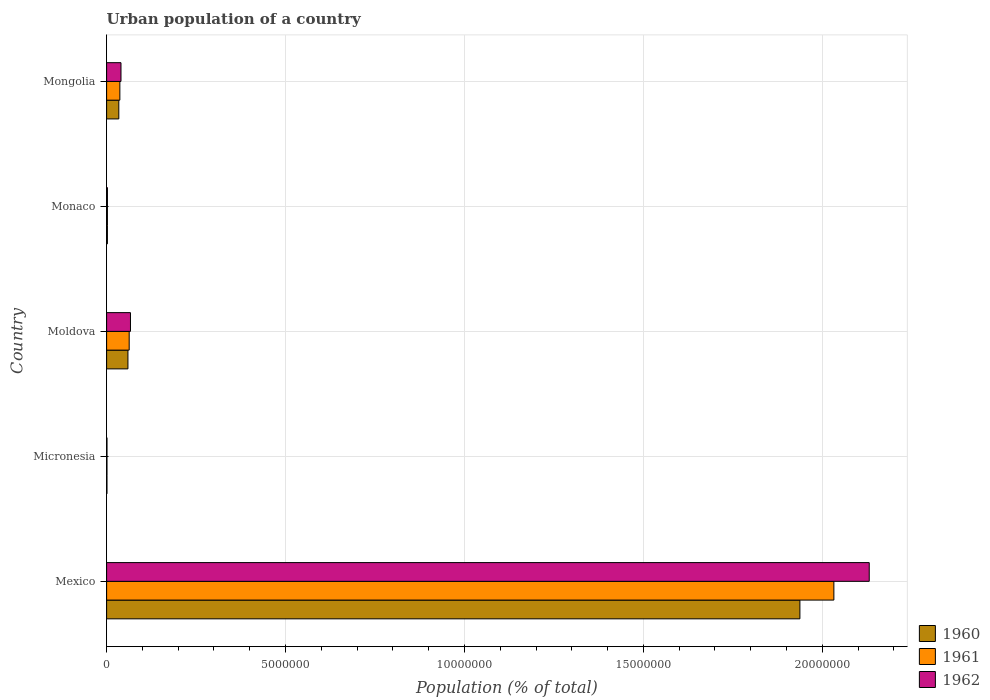How many different coloured bars are there?
Offer a terse response. 3. Are the number of bars on each tick of the Y-axis equal?
Your response must be concise. Yes. What is the label of the 3rd group of bars from the top?
Your answer should be compact. Moldova. What is the urban population in 1960 in Mexico?
Ensure brevity in your answer.  1.94e+07. Across all countries, what is the maximum urban population in 1961?
Your answer should be very brief. 2.03e+07. Across all countries, what is the minimum urban population in 1960?
Offer a very short reply. 9938. In which country was the urban population in 1962 maximum?
Keep it short and to the point. Mexico. In which country was the urban population in 1961 minimum?
Provide a short and direct response. Micronesia. What is the total urban population in 1962 in the graph?
Make the answer very short. 2.24e+07. What is the difference between the urban population in 1962 in Micronesia and that in Monaco?
Your answer should be compact. -1.22e+04. What is the difference between the urban population in 1962 in Monaco and the urban population in 1960 in Micronesia?
Your answer should be compact. 1.31e+04. What is the average urban population in 1960 per country?
Provide a short and direct response. 4.07e+06. What is the difference between the urban population in 1962 and urban population in 1960 in Moldova?
Your answer should be compact. 7.08e+04. What is the ratio of the urban population in 1962 in Mexico to that in Mongolia?
Ensure brevity in your answer.  53.04. Is the urban population in 1960 in Monaco less than that in Mongolia?
Your answer should be compact. Yes. What is the difference between the highest and the second highest urban population in 1961?
Offer a terse response. 1.97e+07. What is the difference between the highest and the lowest urban population in 1960?
Offer a terse response. 1.94e+07. In how many countries, is the urban population in 1962 greater than the average urban population in 1962 taken over all countries?
Your answer should be very brief. 1. What does the 3rd bar from the top in Moldova represents?
Your answer should be very brief. 1960. Is it the case that in every country, the sum of the urban population in 1962 and urban population in 1960 is greater than the urban population in 1961?
Your response must be concise. Yes. How many bars are there?
Offer a terse response. 15. How many countries are there in the graph?
Offer a terse response. 5. Are the values on the major ticks of X-axis written in scientific E-notation?
Ensure brevity in your answer.  No. Does the graph contain grids?
Keep it short and to the point. Yes. Where does the legend appear in the graph?
Ensure brevity in your answer.  Bottom right. How many legend labels are there?
Your response must be concise. 3. What is the title of the graph?
Keep it short and to the point. Urban population of a country. Does "1961" appear as one of the legend labels in the graph?
Make the answer very short. Yes. What is the label or title of the X-axis?
Your answer should be very brief. Population (% of total). What is the Population (% of total) in 1960 in Mexico?
Ensure brevity in your answer.  1.94e+07. What is the Population (% of total) of 1961 in Mexico?
Offer a terse response. 2.03e+07. What is the Population (% of total) of 1962 in Mexico?
Offer a very short reply. 2.13e+07. What is the Population (% of total) in 1960 in Micronesia?
Provide a short and direct response. 9938. What is the Population (% of total) of 1961 in Micronesia?
Give a very brief answer. 1.04e+04. What is the Population (% of total) in 1962 in Micronesia?
Your answer should be very brief. 1.08e+04. What is the Population (% of total) of 1960 in Moldova?
Ensure brevity in your answer.  5.96e+05. What is the Population (% of total) of 1961 in Moldova?
Your answer should be compact. 6.31e+05. What is the Population (% of total) in 1962 in Moldova?
Your answer should be compact. 6.67e+05. What is the Population (% of total) of 1960 in Monaco?
Your response must be concise. 2.25e+04. What is the Population (% of total) in 1961 in Monaco?
Keep it short and to the point. 2.28e+04. What is the Population (% of total) in 1962 in Monaco?
Provide a short and direct response. 2.30e+04. What is the Population (% of total) of 1960 in Mongolia?
Keep it short and to the point. 3.41e+05. What is the Population (% of total) in 1961 in Mongolia?
Make the answer very short. 3.70e+05. What is the Population (% of total) of 1962 in Mongolia?
Your answer should be very brief. 4.02e+05. Across all countries, what is the maximum Population (% of total) in 1960?
Offer a terse response. 1.94e+07. Across all countries, what is the maximum Population (% of total) in 1961?
Keep it short and to the point. 2.03e+07. Across all countries, what is the maximum Population (% of total) of 1962?
Your answer should be compact. 2.13e+07. Across all countries, what is the minimum Population (% of total) of 1960?
Offer a terse response. 9938. Across all countries, what is the minimum Population (% of total) of 1961?
Give a very brief answer. 1.04e+04. Across all countries, what is the minimum Population (% of total) in 1962?
Make the answer very short. 1.08e+04. What is the total Population (% of total) of 1960 in the graph?
Make the answer very short. 2.03e+07. What is the total Population (% of total) in 1961 in the graph?
Your answer should be very brief. 2.14e+07. What is the total Population (% of total) in 1962 in the graph?
Make the answer very short. 2.24e+07. What is the difference between the Population (% of total) in 1960 in Mexico and that in Micronesia?
Your answer should be very brief. 1.94e+07. What is the difference between the Population (% of total) of 1961 in Mexico and that in Micronesia?
Provide a succinct answer. 2.03e+07. What is the difference between the Population (% of total) in 1962 in Mexico and that in Micronesia?
Your answer should be very brief. 2.13e+07. What is the difference between the Population (% of total) of 1960 in Mexico and that in Moldova?
Give a very brief answer. 1.88e+07. What is the difference between the Population (% of total) of 1961 in Mexico and that in Moldova?
Offer a terse response. 1.97e+07. What is the difference between the Population (% of total) in 1962 in Mexico and that in Moldova?
Make the answer very short. 2.06e+07. What is the difference between the Population (% of total) of 1960 in Mexico and that in Monaco?
Keep it short and to the point. 1.94e+07. What is the difference between the Population (% of total) in 1961 in Mexico and that in Monaco?
Keep it short and to the point. 2.03e+07. What is the difference between the Population (% of total) in 1962 in Mexico and that in Monaco?
Your response must be concise. 2.13e+07. What is the difference between the Population (% of total) of 1960 in Mexico and that in Mongolia?
Make the answer very short. 1.90e+07. What is the difference between the Population (% of total) of 1961 in Mexico and that in Mongolia?
Provide a succinct answer. 2.00e+07. What is the difference between the Population (% of total) in 1962 in Mexico and that in Mongolia?
Offer a very short reply. 2.09e+07. What is the difference between the Population (% of total) in 1960 in Micronesia and that in Moldova?
Your answer should be compact. -5.86e+05. What is the difference between the Population (% of total) in 1961 in Micronesia and that in Moldova?
Provide a short and direct response. -6.20e+05. What is the difference between the Population (% of total) in 1962 in Micronesia and that in Moldova?
Your response must be concise. -6.56e+05. What is the difference between the Population (% of total) of 1960 in Micronesia and that in Monaco?
Provide a succinct answer. -1.25e+04. What is the difference between the Population (% of total) of 1961 in Micronesia and that in Monaco?
Provide a succinct answer. -1.24e+04. What is the difference between the Population (% of total) in 1962 in Micronesia and that in Monaco?
Your answer should be very brief. -1.22e+04. What is the difference between the Population (% of total) of 1960 in Micronesia and that in Mongolia?
Provide a succinct answer. -3.31e+05. What is the difference between the Population (% of total) of 1961 in Micronesia and that in Mongolia?
Provide a short and direct response. -3.60e+05. What is the difference between the Population (% of total) of 1962 in Micronesia and that in Mongolia?
Your response must be concise. -3.91e+05. What is the difference between the Population (% of total) of 1960 in Moldova and that in Monaco?
Your answer should be compact. 5.73e+05. What is the difference between the Population (% of total) in 1961 in Moldova and that in Monaco?
Make the answer very short. 6.08e+05. What is the difference between the Population (% of total) of 1962 in Moldova and that in Monaco?
Ensure brevity in your answer.  6.44e+05. What is the difference between the Population (% of total) in 1960 in Moldova and that in Mongolia?
Your response must be concise. 2.55e+05. What is the difference between the Population (% of total) in 1961 in Moldova and that in Mongolia?
Your answer should be compact. 2.61e+05. What is the difference between the Population (% of total) of 1962 in Moldova and that in Mongolia?
Your answer should be very brief. 2.65e+05. What is the difference between the Population (% of total) in 1960 in Monaco and that in Mongolia?
Your response must be concise. -3.18e+05. What is the difference between the Population (% of total) of 1961 in Monaco and that in Mongolia?
Your answer should be compact. -3.47e+05. What is the difference between the Population (% of total) in 1962 in Monaco and that in Mongolia?
Give a very brief answer. -3.79e+05. What is the difference between the Population (% of total) in 1960 in Mexico and the Population (% of total) in 1961 in Micronesia?
Provide a succinct answer. 1.94e+07. What is the difference between the Population (% of total) of 1960 in Mexico and the Population (% of total) of 1962 in Micronesia?
Offer a terse response. 1.94e+07. What is the difference between the Population (% of total) in 1961 in Mexico and the Population (% of total) in 1962 in Micronesia?
Your answer should be compact. 2.03e+07. What is the difference between the Population (% of total) in 1960 in Mexico and the Population (% of total) in 1961 in Moldova?
Give a very brief answer. 1.87e+07. What is the difference between the Population (% of total) in 1960 in Mexico and the Population (% of total) in 1962 in Moldova?
Offer a terse response. 1.87e+07. What is the difference between the Population (% of total) of 1961 in Mexico and the Population (% of total) of 1962 in Moldova?
Provide a short and direct response. 1.97e+07. What is the difference between the Population (% of total) in 1960 in Mexico and the Population (% of total) in 1961 in Monaco?
Give a very brief answer. 1.94e+07. What is the difference between the Population (% of total) in 1960 in Mexico and the Population (% of total) in 1962 in Monaco?
Ensure brevity in your answer.  1.94e+07. What is the difference between the Population (% of total) of 1961 in Mexico and the Population (% of total) of 1962 in Monaco?
Provide a short and direct response. 2.03e+07. What is the difference between the Population (% of total) of 1960 in Mexico and the Population (% of total) of 1961 in Mongolia?
Make the answer very short. 1.90e+07. What is the difference between the Population (% of total) in 1960 in Mexico and the Population (% of total) in 1962 in Mongolia?
Your response must be concise. 1.90e+07. What is the difference between the Population (% of total) of 1961 in Mexico and the Population (% of total) of 1962 in Mongolia?
Offer a terse response. 1.99e+07. What is the difference between the Population (% of total) of 1960 in Micronesia and the Population (% of total) of 1961 in Moldova?
Your answer should be very brief. -6.21e+05. What is the difference between the Population (% of total) of 1960 in Micronesia and the Population (% of total) of 1962 in Moldova?
Your answer should be compact. -6.57e+05. What is the difference between the Population (% of total) of 1961 in Micronesia and the Population (% of total) of 1962 in Moldova?
Make the answer very short. -6.56e+05. What is the difference between the Population (% of total) of 1960 in Micronesia and the Population (% of total) of 1961 in Monaco?
Make the answer very short. -1.29e+04. What is the difference between the Population (% of total) in 1960 in Micronesia and the Population (% of total) in 1962 in Monaco?
Your answer should be compact. -1.31e+04. What is the difference between the Population (% of total) in 1961 in Micronesia and the Population (% of total) in 1962 in Monaco?
Keep it short and to the point. -1.27e+04. What is the difference between the Population (% of total) in 1960 in Micronesia and the Population (% of total) in 1961 in Mongolia?
Ensure brevity in your answer.  -3.60e+05. What is the difference between the Population (% of total) of 1960 in Micronesia and the Population (% of total) of 1962 in Mongolia?
Provide a succinct answer. -3.92e+05. What is the difference between the Population (% of total) in 1961 in Micronesia and the Population (% of total) in 1962 in Mongolia?
Keep it short and to the point. -3.91e+05. What is the difference between the Population (% of total) of 1960 in Moldova and the Population (% of total) of 1961 in Monaco?
Keep it short and to the point. 5.73e+05. What is the difference between the Population (% of total) of 1960 in Moldova and the Population (% of total) of 1962 in Monaco?
Offer a terse response. 5.73e+05. What is the difference between the Population (% of total) in 1961 in Moldova and the Population (% of total) in 1962 in Monaco?
Provide a short and direct response. 6.08e+05. What is the difference between the Population (% of total) in 1960 in Moldova and the Population (% of total) in 1961 in Mongolia?
Your answer should be very brief. 2.26e+05. What is the difference between the Population (% of total) in 1960 in Moldova and the Population (% of total) in 1962 in Mongolia?
Give a very brief answer. 1.94e+05. What is the difference between the Population (% of total) in 1961 in Moldova and the Population (% of total) in 1962 in Mongolia?
Give a very brief answer. 2.29e+05. What is the difference between the Population (% of total) of 1960 in Monaco and the Population (% of total) of 1961 in Mongolia?
Offer a very short reply. -3.48e+05. What is the difference between the Population (% of total) of 1960 in Monaco and the Population (% of total) of 1962 in Mongolia?
Provide a succinct answer. -3.79e+05. What is the difference between the Population (% of total) in 1961 in Monaco and the Population (% of total) in 1962 in Mongolia?
Give a very brief answer. -3.79e+05. What is the average Population (% of total) of 1960 per country?
Your answer should be very brief. 4.07e+06. What is the average Population (% of total) in 1961 per country?
Offer a very short reply. 4.27e+06. What is the average Population (% of total) of 1962 per country?
Provide a succinct answer. 4.48e+06. What is the difference between the Population (% of total) of 1960 and Population (% of total) of 1961 in Mexico?
Provide a succinct answer. -9.49e+05. What is the difference between the Population (% of total) in 1960 and Population (% of total) in 1962 in Mexico?
Give a very brief answer. -1.94e+06. What is the difference between the Population (% of total) in 1961 and Population (% of total) in 1962 in Mexico?
Make the answer very short. -9.88e+05. What is the difference between the Population (% of total) in 1960 and Population (% of total) in 1961 in Micronesia?
Your response must be concise. -426. What is the difference between the Population (% of total) of 1960 and Population (% of total) of 1962 in Micronesia?
Give a very brief answer. -865. What is the difference between the Population (% of total) of 1961 and Population (% of total) of 1962 in Micronesia?
Provide a short and direct response. -439. What is the difference between the Population (% of total) in 1960 and Population (% of total) in 1961 in Moldova?
Ensure brevity in your answer.  -3.49e+04. What is the difference between the Population (% of total) of 1960 and Population (% of total) of 1962 in Moldova?
Offer a terse response. -7.08e+04. What is the difference between the Population (% of total) of 1961 and Population (% of total) of 1962 in Moldova?
Ensure brevity in your answer.  -3.59e+04. What is the difference between the Population (% of total) in 1960 and Population (% of total) in 1961 in Monaco?
Offer a terse response. -358. What is the difference between the Population (% of total) in 1960 and Population (% of total) in 1962 in Monaco?
Make the answer very short. -588. What is the difference between the Population (% of total) in 1961 and Population (% of total) in 1962 in Monaco?
Your answer should be compact. -230. What is the difference between the Population (% of total) in 1960 and Population (% of total) in 1961 in Mongolia?
Your response must be concise. -2.92e+04. What is the difference between the Population (% of total) of 1960 and Population (% of total) of 1962 in Mongolia?
Your answer should be very brief. -6.09e+04. What is the difference between the Population (% of total) in 1961 and Population (% of total) in 1962 in Mongolia?
Provide a succinct answer. -3.17e+04. What is the ratio of the Population (% of total) of 1960 in Mexico to that in Micronesia?
Your answer should be very brief. 1949.54. What is the ratio of the Population (% of total) in 1961 in Mexico to that in Micronesia?
Offer a very short reply. 1960.96. What is the ratio of the Population (% of total) in 1962 in Mexico to that in Micronesia?
Keep it short and to the point. 1972.76. What is the ratio of the Population (% of total) in 1960 in Mexico to that in Moldova?
Make the answer very short. 32.51. What is the ratio of the Population (% of total) in 1961 in Mexico to that in Moldova?
Give a very brief answer. 32.22. What is the ratio of the Population (% of total) in 1962 in Mexico to that in Moldova?
Your answer should be compact. 31.97. What is the ratio of the Population (% of total) of 1960 in Mexico to that in Monaco?
Your answer should be compact. 862.85. What is the ratio of the Population (% of total) of 1961 in Mexico to that in Monaco?
Keep it short and to the point. 890.91. What is the ratio of the Population (% of total) of 1962 in Mexico to that in Monaco?
Offer a very short reply. 924.91. What is the ratio of the Population (% of total) of 1960 in Mexico to that in Mongolia?
Make the answer very short. 56.83. What is the ratio of the Population (% of total) of 1961 in Mexico to that in Mongolia?
Your response must be concise. 54.91. What is the ratio of the Population (% of total) of 1962 in Mexico to that in Mongolia?
Provide a short and direct response. 53.04. What is the ratio of the Population (% of total) in 1960 in Micronesia to that in Moldova?
Your answer should be very brief. 0.02. What is the ratio of the Population (% of total) of 1961 in Micronesia to that in Moldova?
Offer a terse response. 0.02. What is the ratio of the Population (% of total) in 1962 in Micronesia to that in Moldova?
Offer a terse response. 0.02. What is the ratio of the Population (% of total) of 1960 in Micronesia to that in Monaco?
Provide a succinct answer. 0.44. What is the ratio of the Population (% of total) of 1961 in Micronesia to that in Monaco?
Offer a terse response. 0.45. What is the ratio of the Population (% of total) in 1962 in Micronesia to that in Monaco?
Keep it short and to the point. 0.47. What is the ratio of the Population (% of total) in 1960 in Micronesia to that in Mongolia?
Provide a short and direct response. 0.03. What is the ratio of the Population (% of total) in 1961 in Micronesia to that in Mongolia?
Provide a short and direct response. 0.03. What is the ratio of the Population (% of total) of 1962 in Micronesia to that in Mongolia?
Ensure brevity in your answer.  0.03. What is the ratio of the Population (% of total) in 1960 in Moldova to that in Monaco?
Your answer should be compact. 26.54. What is the ratio of the Population (% of total) of 1961 in Moldova to that in Monaco?
Provide a succinct answer. 27.65. What is the ratio of the Population (% of total) in 1962 in Moldova to that in Monaco?
Keep it short and to the point. 28.93. What is the ratio of the Population (% of total) in 1960 in Moldova to that in Mongolia?
Keep it short and to the point. 1.75. What is the ratio of the Population (% of total) in 1961 in Moldova to that in Mongolia?
Keep it short and to the point. 1.7. What is the ratio of the Population (% of total) in 1962 in Moldova to that in Mongolia?
Offer a terse response. 1.66. What is the ratio of the Population (% of total) of 1960 in Monaco to that in Mongolia?
Make the answer very short. 0.07. What is the ratio of the Population (% of total) of 1961 in Monaco to that in Mongolia?
Provide a short and direct response. 0.06. What is the ratio of the Population (% of total) of 1962 in Monaco to that in Mongolia?
Ensure brevity in your answer.  0.06. What is the difference between the highest and the second highest Population (% of total) of 1960?
Give a very brief answer. 1.88e+07. What is the difference between the highest and the second highest Population (% of total) in 1961?
Offer a terse response. 1.97e+07. What is the difference between the highest and the second highest Population (% of total) in 1962?
Offer a very short reply. 2.06e+07. What is the difference between the highest and the lowest Population (% of total) of 1960?
Provide a short and direct response. 1.94e+07. What is the difference between the highest and the lowest Population (% of total) in 1961?
Your response must be concise. 2.03e+07. What is the difference between the highest and the lowest Population (% of total) of 1962?
Your response must be concise. 2.13e+07. 